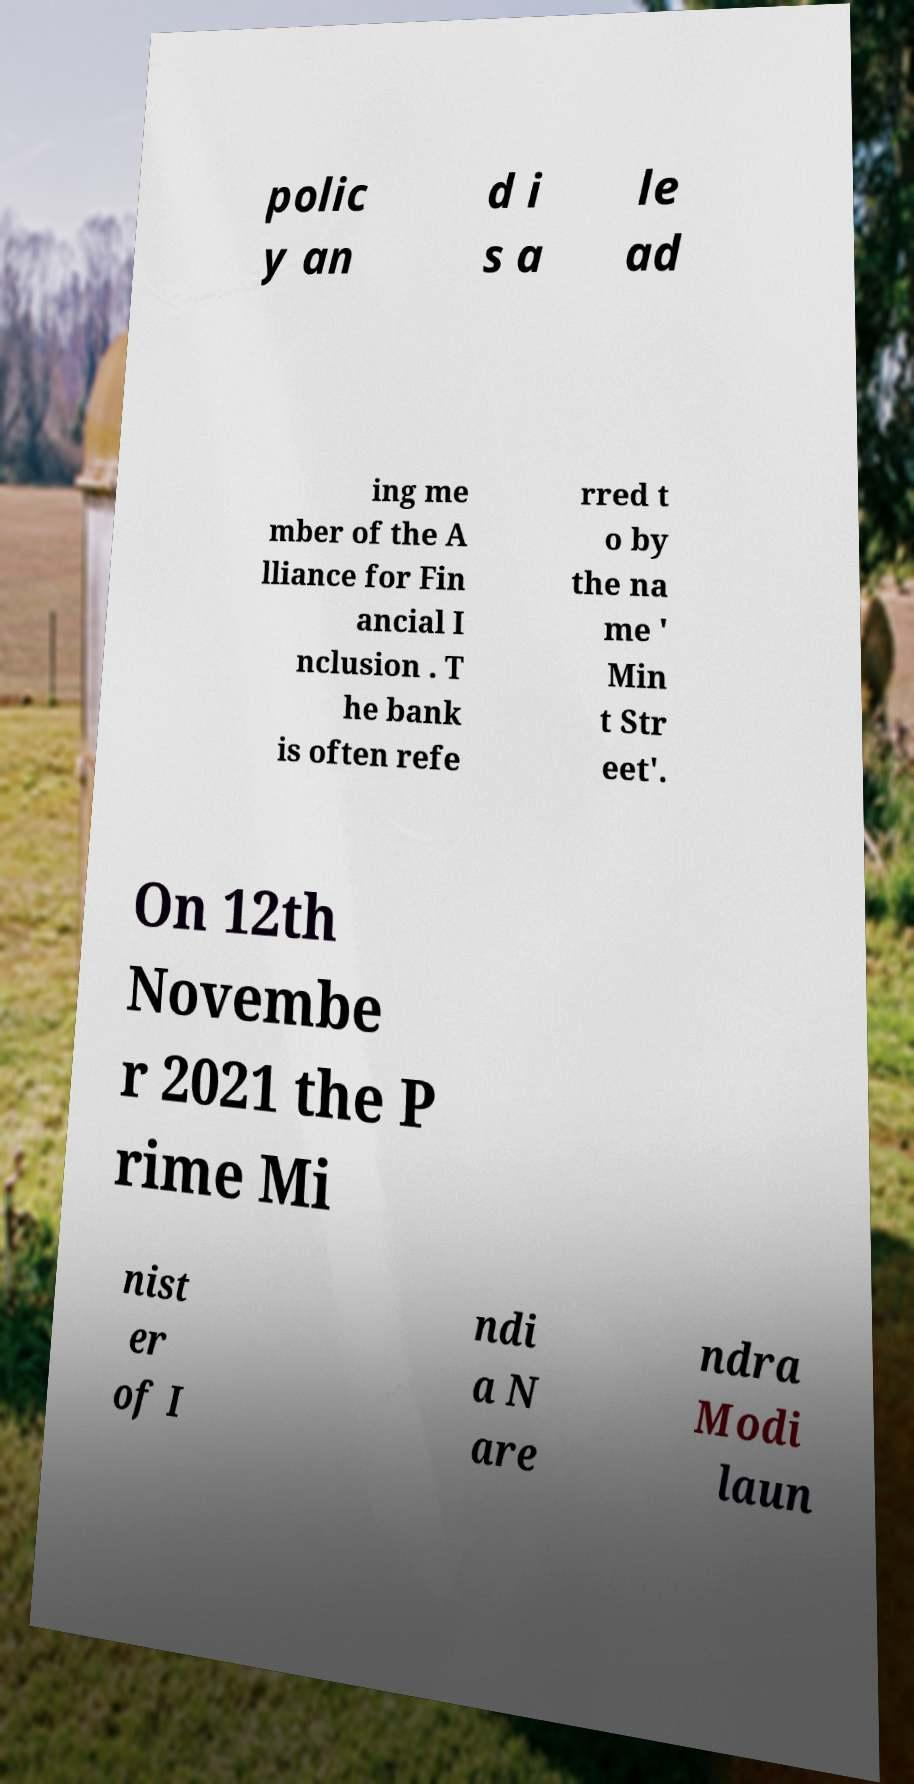Could you extract and type out the text from this image? polic y an d i s a le ad ing me mber of the A lliance for Fin ancial I nclusion . T he bank is often refe rred t o by the na me ' Min t Str eet'. On 12th Novembe r 2021 the P rime Mi nist er of I ndi a N are ndra Modi laun 